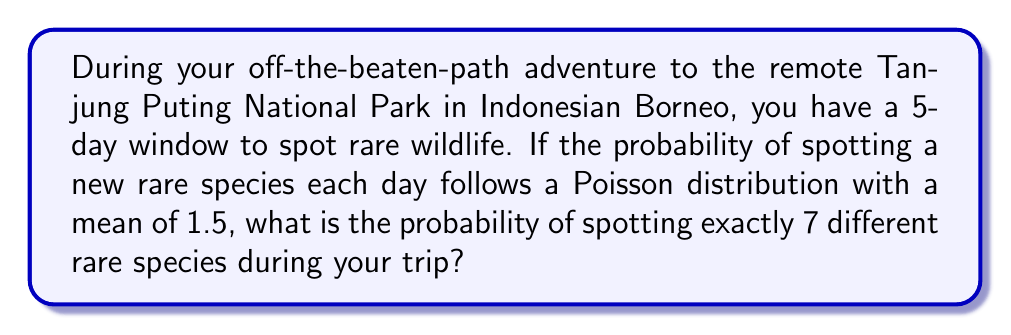Give your solution to this math problem. Let's approach this step-by-step:

1) The scenario follows a Poisson distribution with:
   $\lambda$ (mean) = 1.5 per day
   Number of days = 5

2) For 5 days, the total $\lambda$ becomes:
   $\lambda_{total} = 1.5 \times 5 = 7.5$

3) We want to calculate the probability of spotting exactly 7 species over 5 days.

4) The Poisson probability mass function is:

   $$P(X = k) = \frac{e^{-\lambda}\lambda^k}{k!}$$

   Where:
   $e$ is Euler's number (approximately 2.71828)
   $\lambda$ is the mean number of occurrences
   $k$ is the number of occurrences we're calculating the probability for

5) Substituting our values:

   $$P(X = 7) = \frac{e^{-7.5}7.5^7}{7!}$$

6) Calculate:
   $$P(X = 7) = \frac{2.71828^{-7.5} \times 7.5^7}{7 \times 6 \times 5 \times 4 \times 3 \times 2 \times 1}$$

7) Simplify:
   $$P(X = 7) \approx 0.1234$$

8) Convert to percentage:
   0.1234 × 100% ≈ 12.34%
Answer: 12.34% 